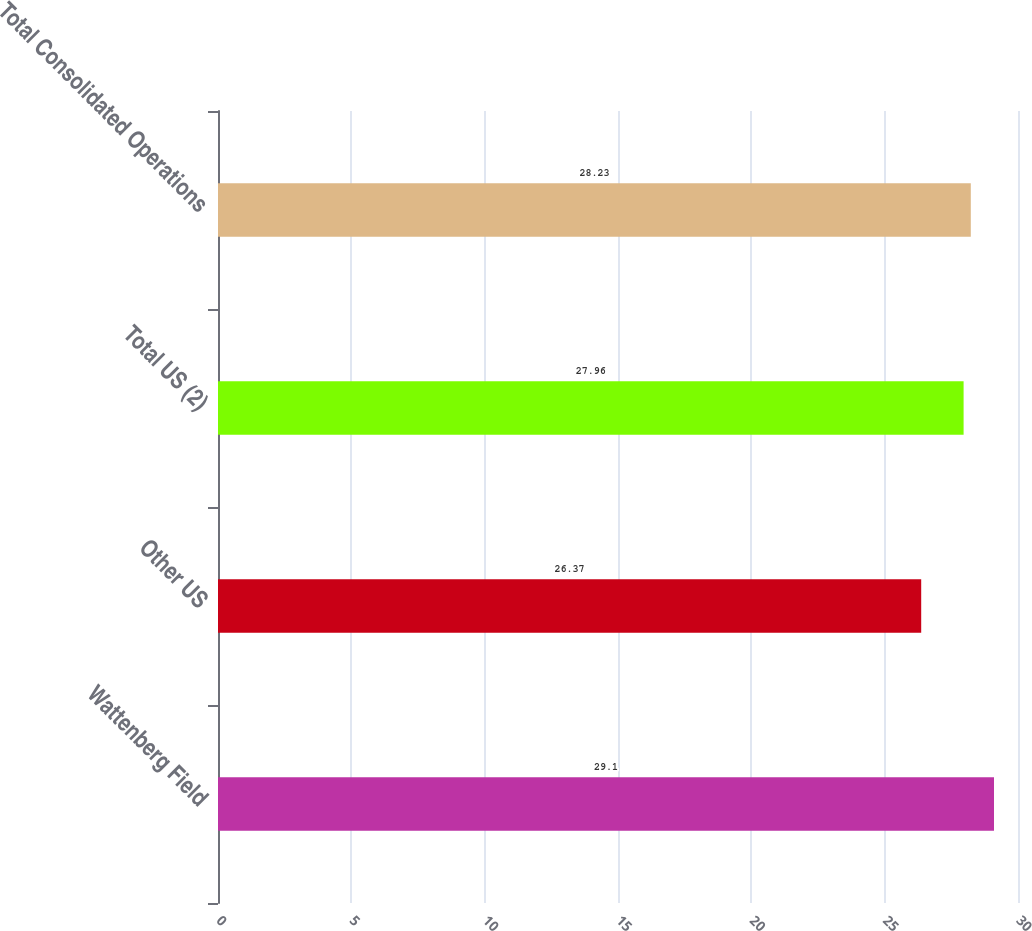Convert chart to OTSL. <chart><loc_0><loc_0><loc_500><loc_500><bar_chart><fcel>Wattenberg Field<fcel>Other US<fcel>Total US (2)<fcel>Total Consolidated Operations<nl><fcel>29.1<fcel>26.37<fcel>27.96<fcel>28.23<nl></chart> 